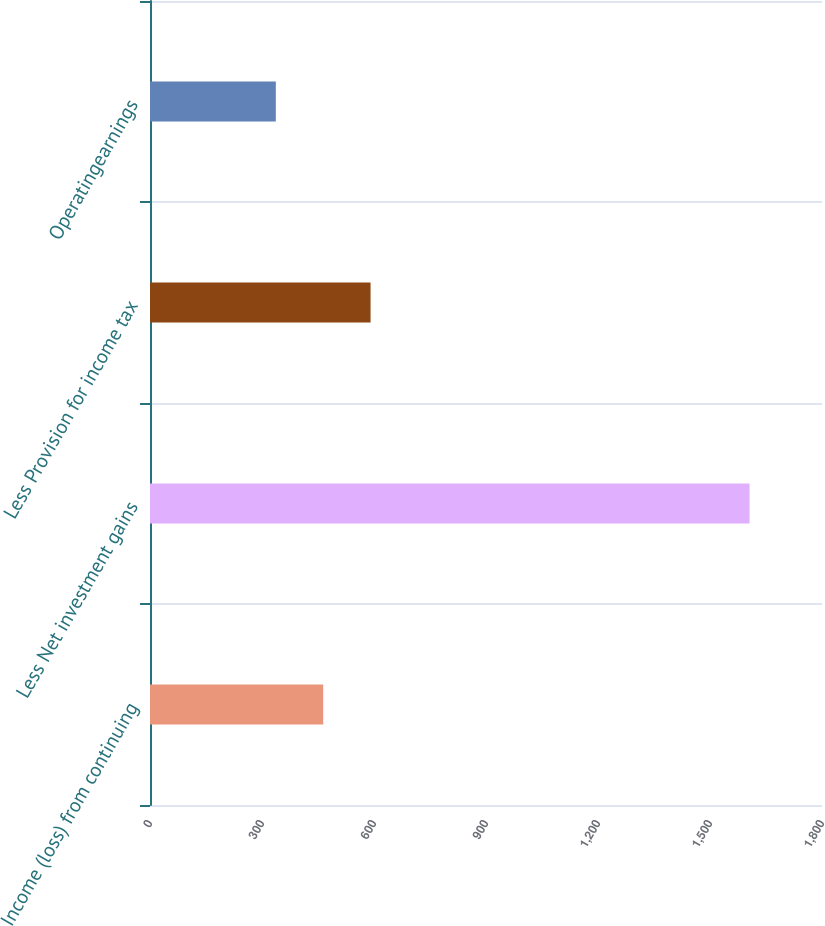<chart> <loc_0><loc_0><loc_500><loc_500><bar_chart><fcel>Income (loss) from continuing<fcel>Less Net investment gains<fcel>Less Provision for income tax<fcel>Operatingearnings<nl><fcel>463.9<fcel>1606<fcel>590.8<fcel>337<nl></chart> 